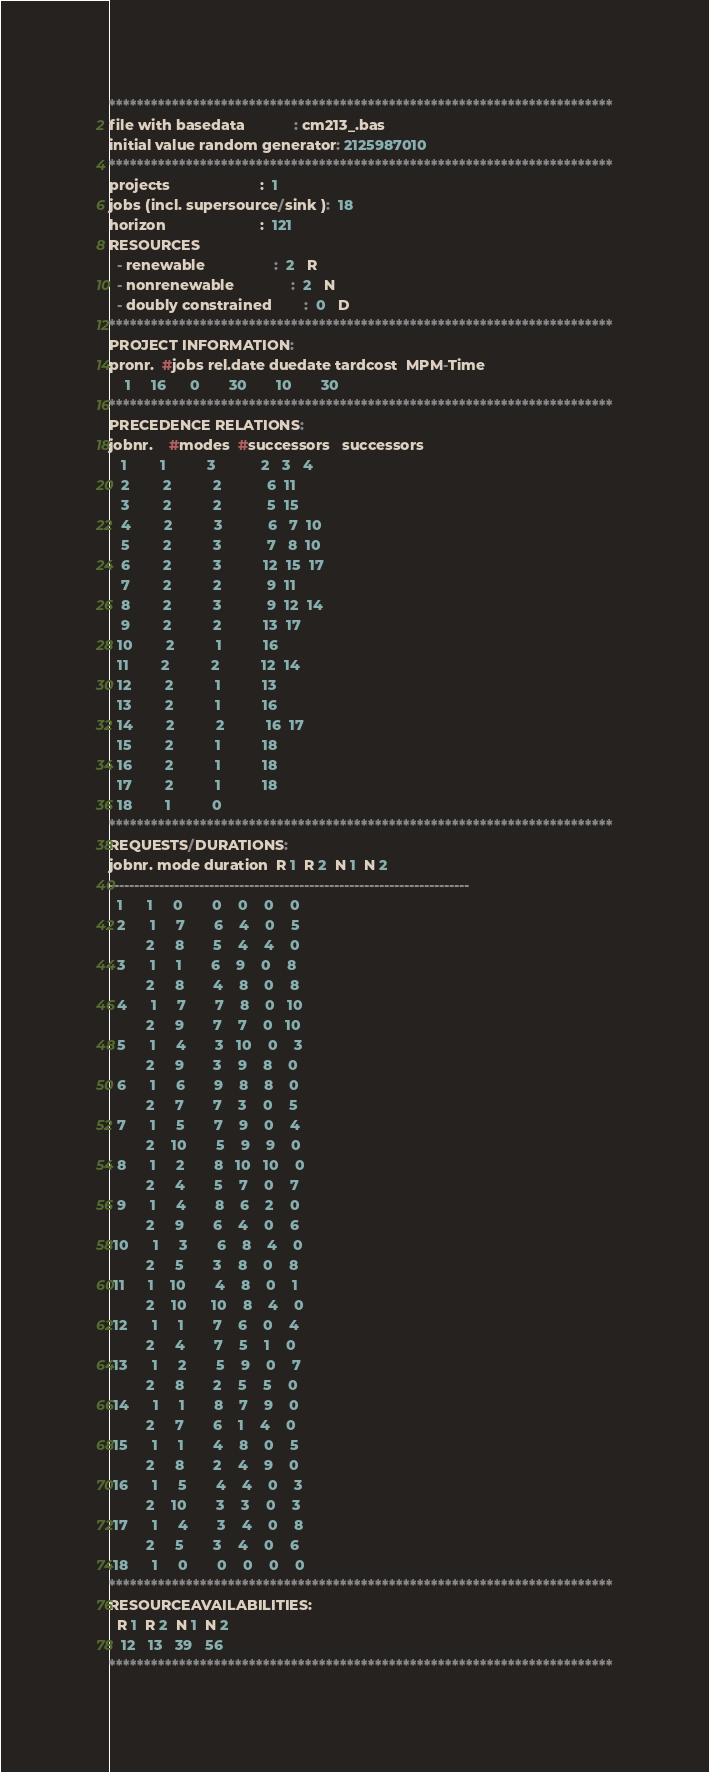Convert code to text. <code><loc_0><loc_0><loc_500><loc_500><_ObjectiveC_>************************************************************************
file with basedata            : cm213_.bas
initial value random generator: 2125987010
************************************************************************
projects                      :  1
jobs (incl. supersource/sink ):  18
horizon                       :  121
RESOURCES
  - renewable                 :  2   R
  - nonrenewable              :  2   N
  - doubly constrained        :  0   D
************************************************************************
PROJECT INFORMATION:
pronr.  #jobs rel.date duedate tardcost  MPM-Time
    1     16      0       30       10       30
************************************************************************
PRECEDENCE RELATIONS:
jobnr.    #modes  #successors   successors
   1        1          3           2   3   4
   2        2          2           6  11
   3        2          2           5  15
   4        2          3           6   7  10
   5        2          3           7   8  10
   6        2          3          12  15  17
   7        2          2           9  11
   8        2          3           9  12  14
   9        2          2          13  17
  10        2          1          16
  11        2          2          12  14
  12        2          1          13
  13        2          1          16
  14        2          2          16  17
  15        2          1          18
  16        2          1          18
  17        2          1          18
  18        1          0        
************************************************************************
REQUESTS/DURATIONS:
jobnr. mode duration  R 1  R 2  N 1  N 2
------------------------------------------------------------------------
  1      1     0       0    0    0    0
  2      1     7       6    4    0    5
         2     8       5    4    4    0
  3      1     1       6    9    0    8
         2     8       4    8    0    8
  4      1     7       7    8    0   10
         2     9       7    7    0   10
  5      1     4       3   10    0    3
         2     9       3    9    8    0
  6      1     6       9    8    8    0
         2     7       7    3    0    5
  7      1     5       7    9    0    4
         2    10       5    9    9    0
  8      1     2       8   10   10    0
         2     4       5    7    0    7
  9      1     4       8    6    2    0
         2     9       6    4    0    6
 10      1     3       6    8    4    0
         2     5       3    8    0    8
 11      1    10       4    8    0    1
         2    10      10    8    4    0
 12      1     1       7    6    0    4
         2     4       7    5    1    0
 13      1     2       5    9    0    7
         2     8       2    5    5    0
 14      1     1       8    7    9    0
         2     7       6    1    4    0
 15      1     1       4    8    0    5
         2     8       2    4    9    0
 16      1     5       4    4    0    3
         2    10       3    3    0    3
 17      1     4       3    4    0    8
         2     5       3    4    0    6
 18      1     0       0    0    0    0
************************************************************************
RESOURCEAVAILABILITIES:
  R 1  R 2  N 1  N 2
   12   13   39   56
************************************************************************
</code> 